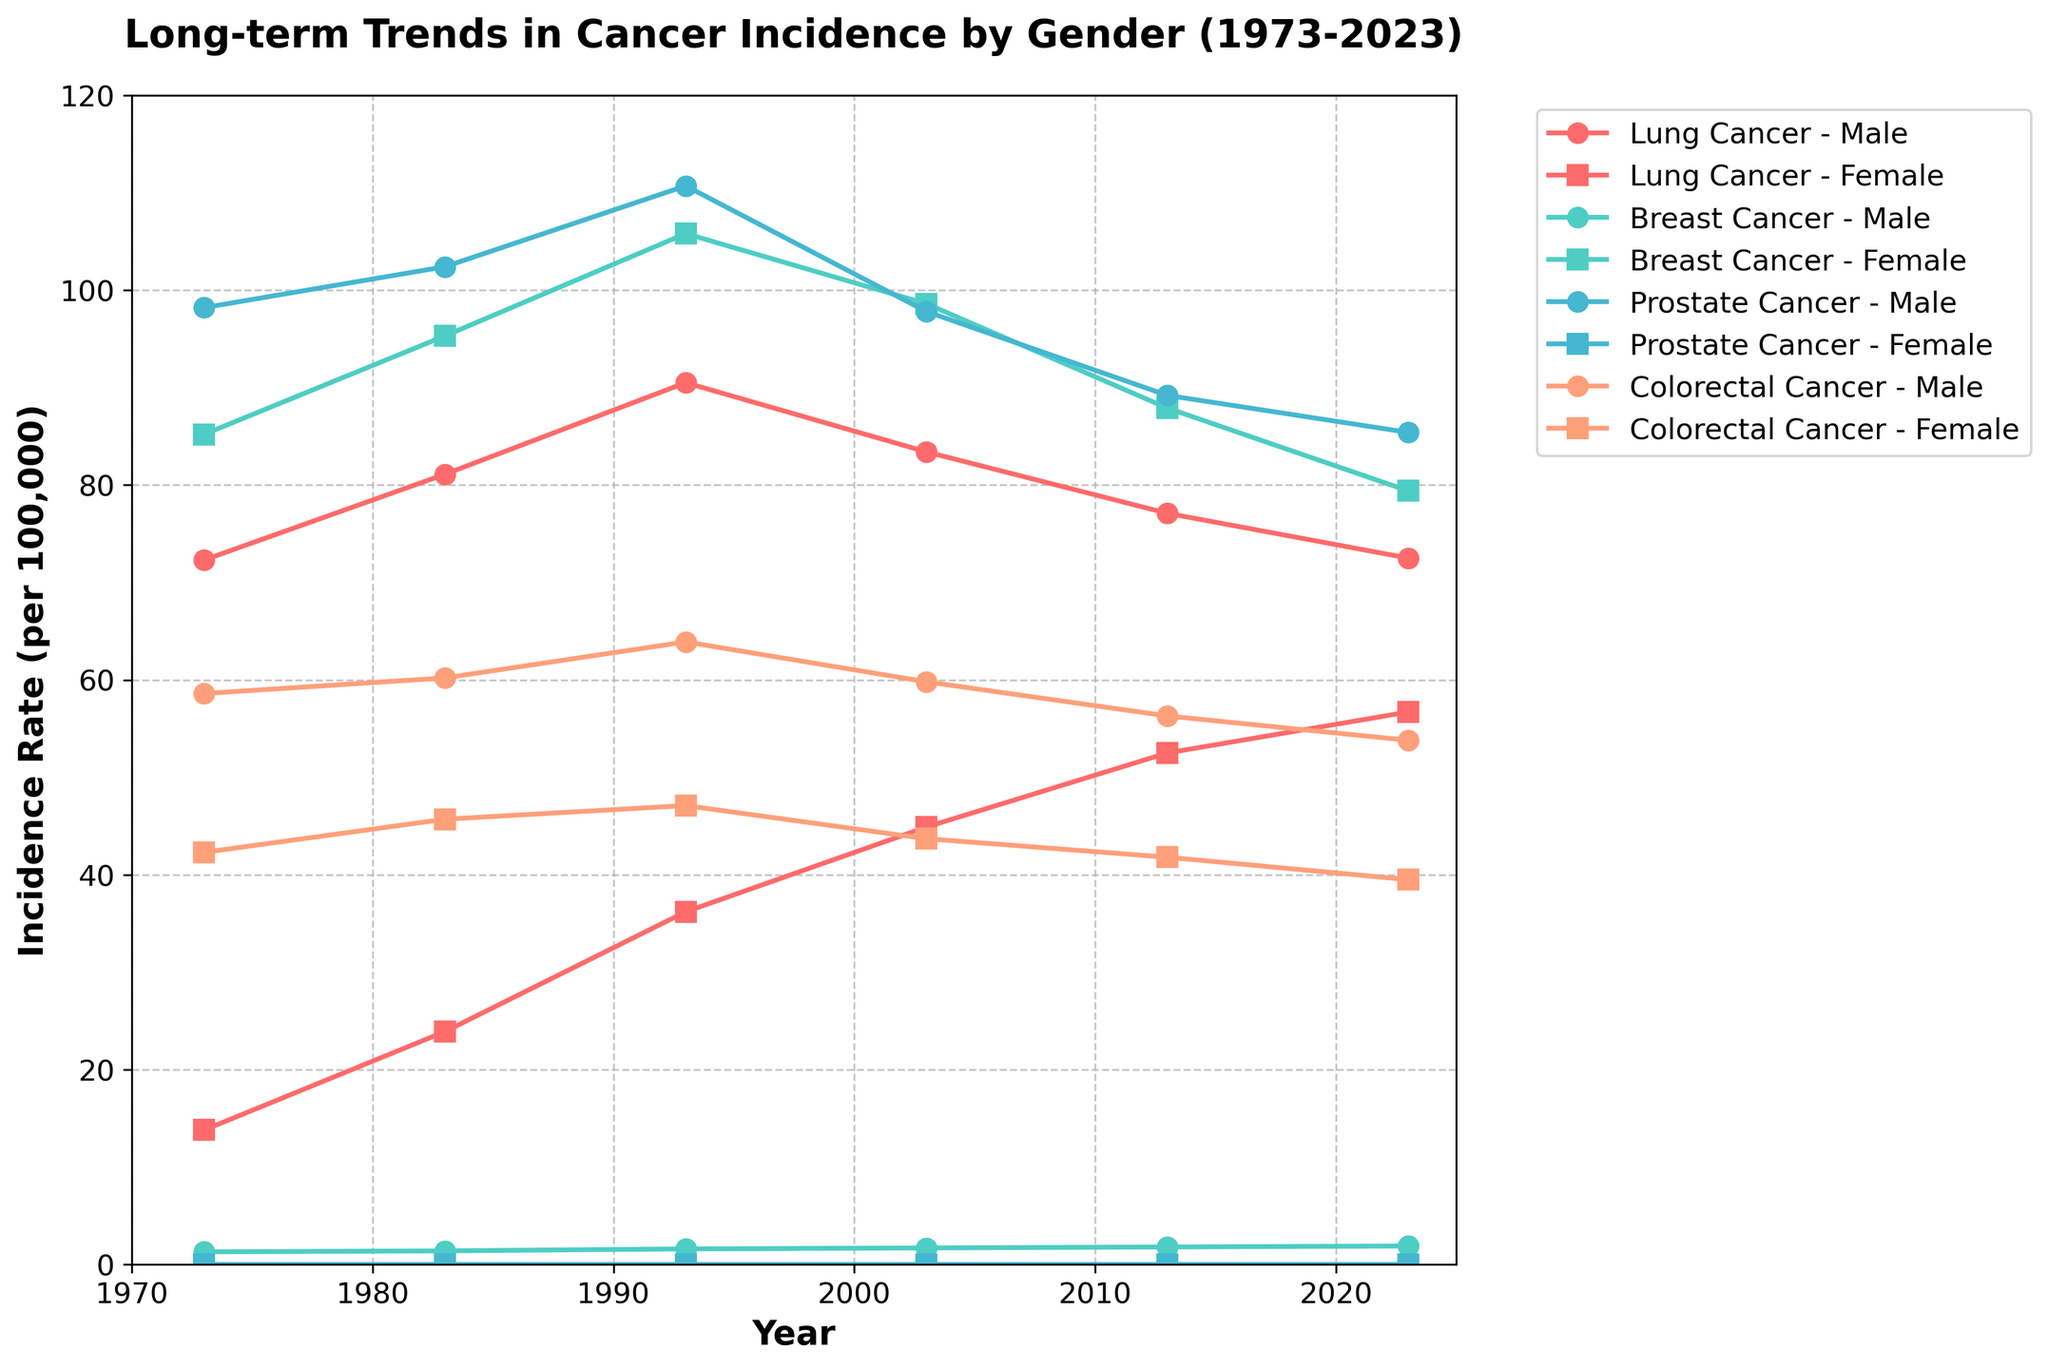What's the title of the plot? The title of the plot is located at the top of the figure. It reads, "Long-term Trends in Cancer Incidence by Gender (1973-2023)", which gives context about the time range and the types of trends shown.
Answer: Long-term Trends in Cancer Incidence by Gender (1973-2023) What is the incidence rate of Lung Cancer in females in 2023? To find this, look for the data points for Lung Cancer, specifically marked by squares (indicating female) in the year 2023. The point aligns with an incidence rate.
Answer: 56.7 What is the trend of Breast Cancer incidence in males over the years? By observing the plot markers (circles for males) corresponding to Breast Cancer, you can see the trend line from 1973 to 2023. The incidence rate shows a gradual increase over the years.
Answer: Gradual increase Compare the incidence rate of Colorectal Cancer between males and females in 1993. Which is higher? Locate the year 1993 on the x-axis and compare the markers for Colorectal Cancer (color coded) for males (circles) and females (squares). The incidence rate for males is higher in 1993.
Answer: Males What is the difference in the incidence rate of Lung Cancer between males and females in 1973? Identify the Lung Cancer incidence rates for both males and females in 1973. Subtract the female rate from the male rate: 72.3 - 13.8 = 58.5.
Answer: 58.5 Which cancer type has shown a consistent trend of having zero incidence in females over the years? By checking all the points plotted for females and identifying any cancer type that consistently shows zero incidence, we find that Prostate Cancer has zero incidence for females over all years.
Answer: Prostate Cancer How has the incidence rate of Lung Cancer in males changed from 1973 to 2023? Look at the data points for Lung Cancer in males over the years 1973 to 2023. Starting at 72.3 in 1973, it reached higher values but dropped back to 72.5 by 2023, indicating a relatively stable trend with some fluctuation.
Answer: Relatively stable with fluctuation What cancer type shows the greatest difference in incidence rates between genders in 2023? Examine the incidence rates for each cancer type in 2023 for both genders. The greatest difference is evident in Breast Cancer (79.4 for females and 1.9 for males, difference of 77.5).
Answer: Breast Cancer What's the average incidence rate of Lung Cancer in females between 1973 and 2023? Calculate the average by summing the data values for Lung Cancer in females (13.8, 23.9, 36.2, 44.9, 52.5, 56.7) and dividing by the number of points (6). (13.8 + 23.9 + 36.2 + 44.9 + 52.5 + 56.7) / 6 = 37.97
Answer: 37.97 